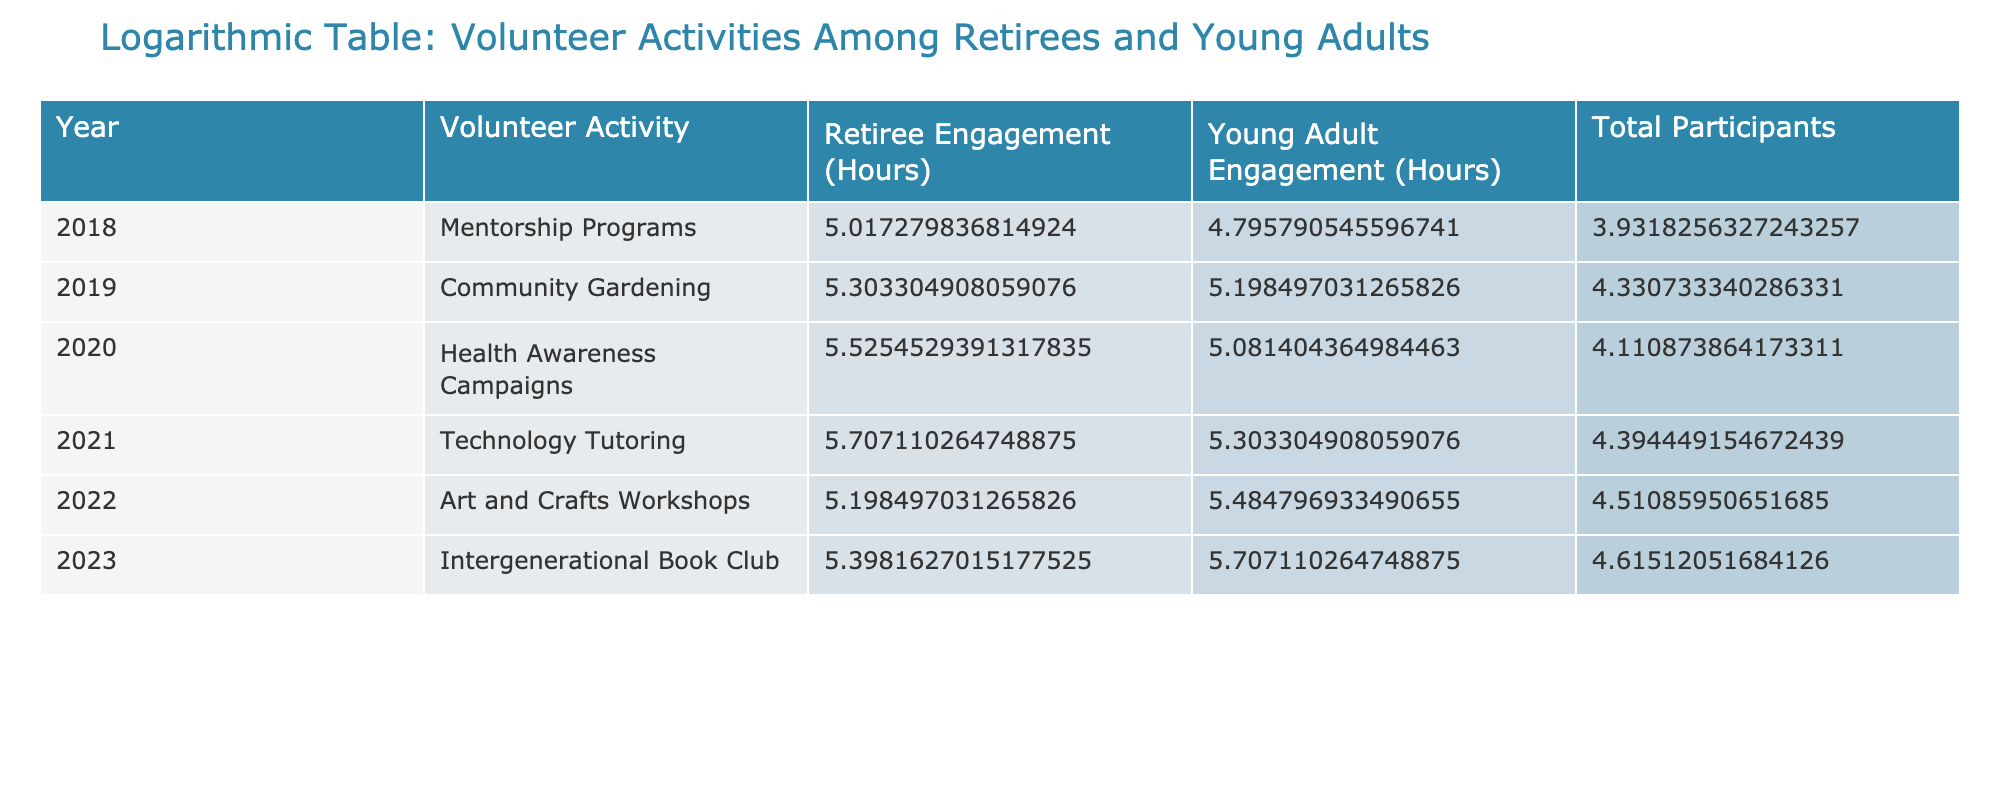What was the total volunteer engagement of retirees in 2021? The table shows that the "Retiree Engagement (Hours)" for 2021 is listed directly as 300 hours.
Answer: 300 hours Which volunteer activity had the highest young adult engagement in 2022? From the table, we see that in 2022, "Art and Crafts Workshops" had a young adult engagement of 240 hours, which is the highest value listed for that year.
Answer: Art and Crafts Workshops How many total participants were involved in volunteer activities in 2019? The table indicates that for 2019, the total number of participants is 75, which is highlighted in the Total Participants column.
Answer: 75 What is the difference in volunteer engagement hours between retirees and young adults for the year 2020? In 2020, the retiree engagement is 250 hours and young adult engagement is 160 hours. The difference is calculated as 250 - 160 = 90 hours.
Answer: 90 hours Did more retirees or young adults engage in volunteer activities in 2023? According to the table for 2023, retirees engaged for 220 hours while young adults engaged for 300 hours. Since 300 is greater than 220, it shows that more young adults participated.
Answer: No What was the average retiree engagement over the years recorded in the data? To find the average, sum the retiree hours for all years: 150 + 200 + 250 + 300 + 180 + 220 = 1300. There are 6 years, so 1300/6 = approximately 216.67 hours.
Answer: Approximately 216.67 hours Which year saw the lowest total participant engagement, and what was it? By examining the "Total Participants" column, the lowest value is 50 in the year 2018. This indicates it was the year with the least engagement.
Answer: 2018, 50 participants What trend can be observed in the young adult engagement hours from 2018 to 2023? Looking at the "Young Adult Engagement (Hours)" column, the hours show an increasing trend from 120 in 2018 to 300 in 2023, indicating a steady rise in engagement over the years.
Answer: Increasing trend How many more hours did retirees engage in 2022 compared to 2018? In 2022, retirees engaged for 180 hours and in 2018 for 150 hours. The difference is calculated as 180 - 150 = 30 hours.
Answer: 30 hours 